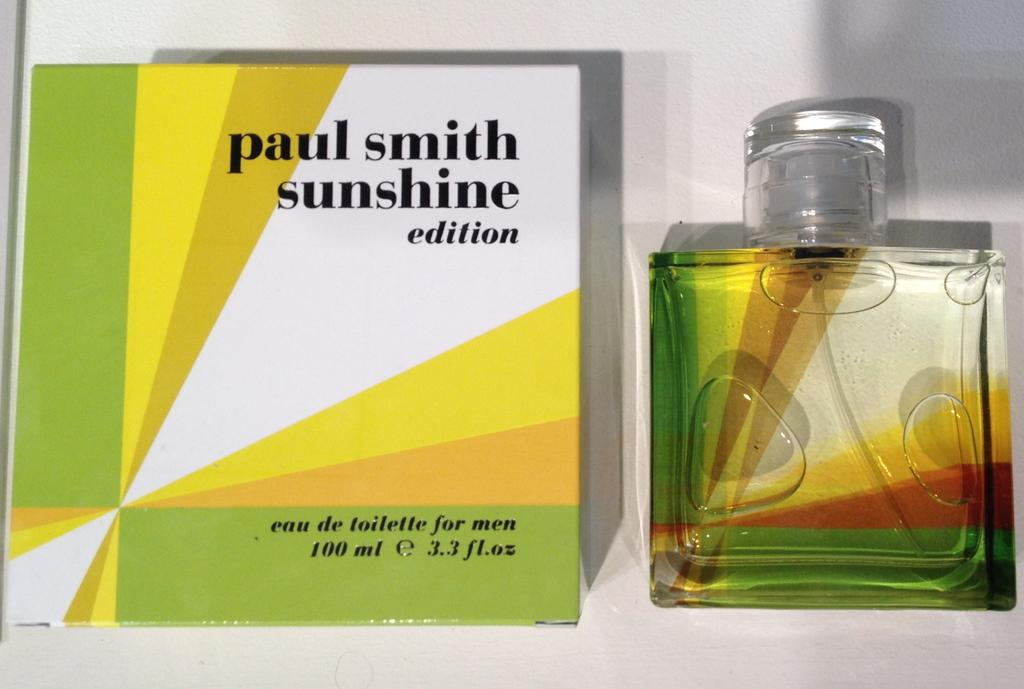<image>
Render a clear and concise summary of the photo. Clear cologne bottle next to a green, yellow, and orange Paul Smith box. 